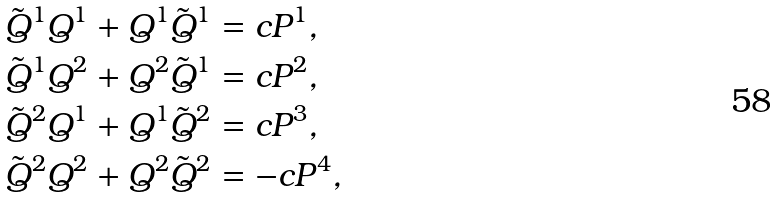<formula> <loc_0><loc_0><loc_500><loc_500>\tilde { Q } ^ { 1 } Q ^ { 1 } + Q ^ { 1 } \tilde { Q } ^ { 1 } & = c P ^ { 1 } , \\ \tilde { Q } ^ { 1 } Q ^ { 2 } + Q ^ { 2 } \tilde { Q } ^ { 1 } & = c P ^ { 2 } , \\ \tilde { Q } ^ { 2 } Q ^ { 1 } + Q ^ { 1 } \tilde { Q } ^ { 2 } & = c P ^ { 3 } , \\ \tilde { Q } ^ { 2 } Q ^ { 2 } + Q ^ { 2 } \tilde { Q } ^ { 2 } & = - c P ^ { 4 } ,</formula> 